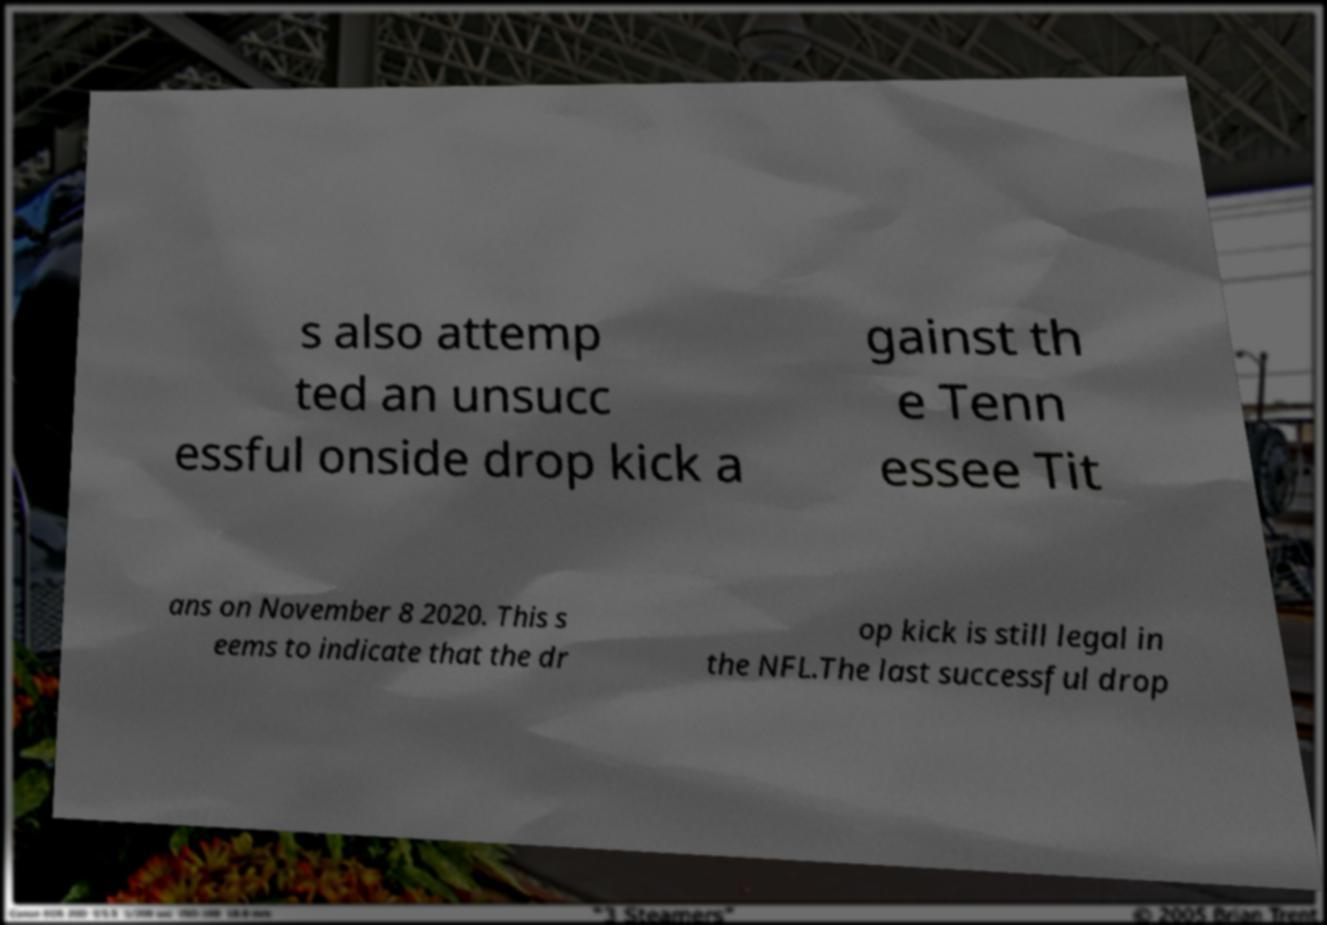For documentation purposes, I need the text within this image transcribed. Could you provide that? s also attemp ted an unsucc essful onside drop kick a gainst th e Tenn essee Tit ans on November 8 2020. This s eems to indicate that the dr op kick is still legal in the NFL.The last successful drop 